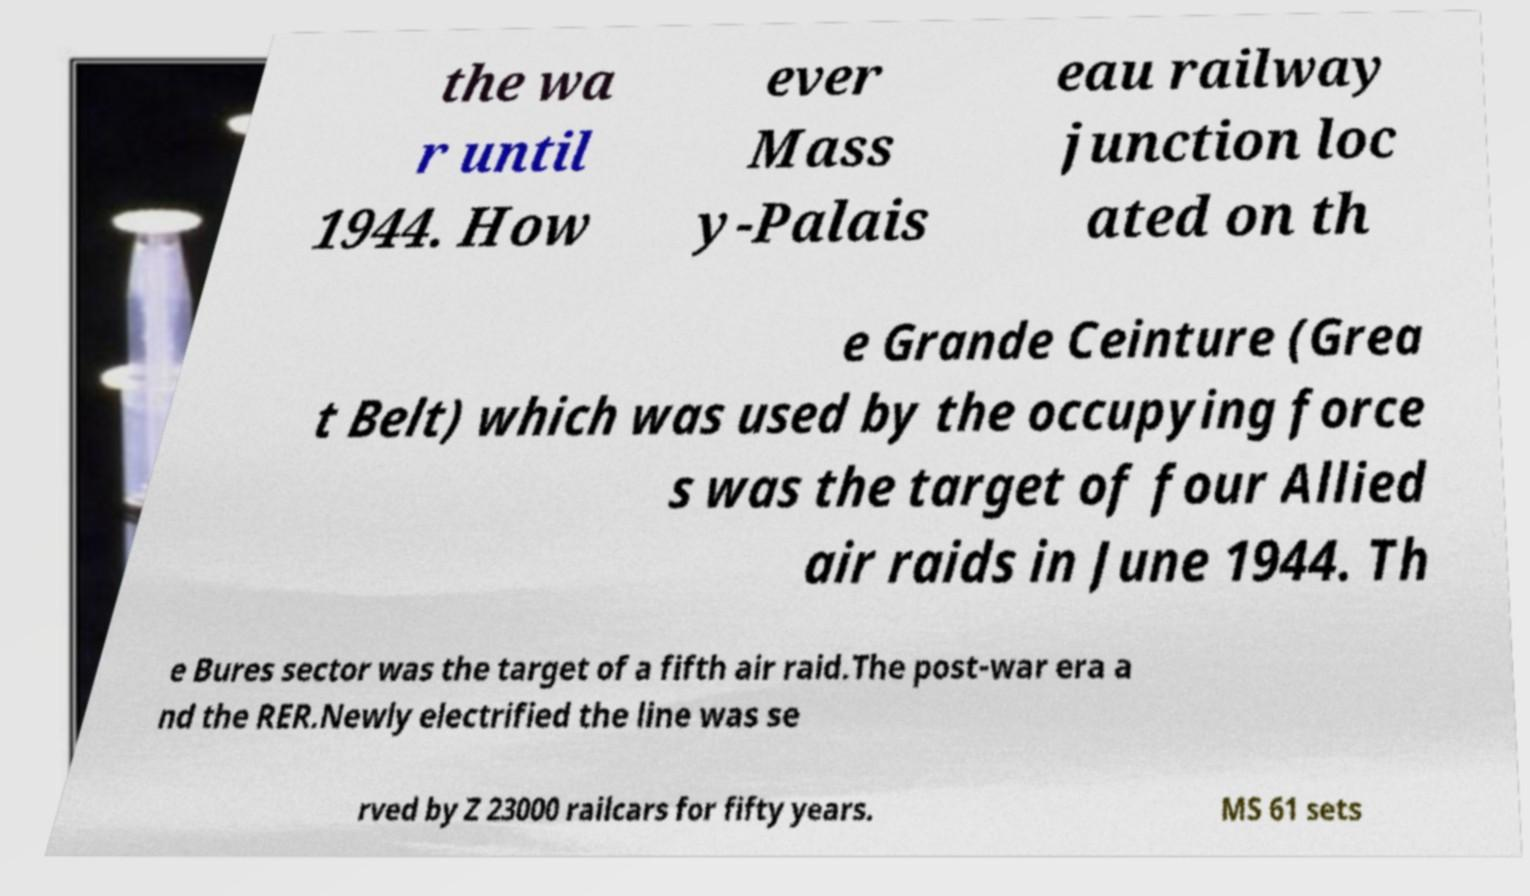Could you extract and type out the text from this image? the wa r until 1944. How ever Mass y-Palais eau railway junction loc ated on th e Grande Ceinture (Grea t Belt) which was used by the occupying force s was the target of four Allied air raids in June 1944. Th e Bures sector was the target of a fifth air raid.The post-war era a nd the RER.Newly electrified the line was se rved by Z 23000 railcars for fifty years. MS 61 sets 